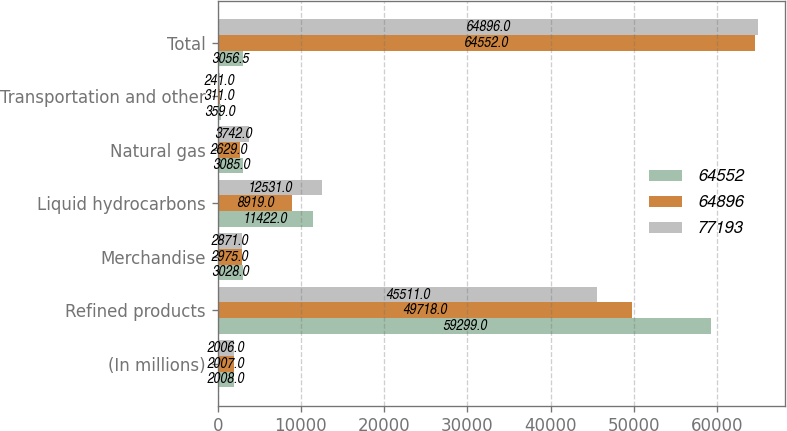<chart> <loc_0><loc_0><loc_500><loc_500><stacked_bar_chart><ecel><fcel>(In millions)<fcel>Refined products<fcel>Merchandise<fcel>Liquid hydrocarbons<fcel>Natural gas<fcel>Transportation and other<fcel>Total<nl><fcel>64552<fcel>2008<fcel>59299<fcel>3028<fcel>11422<fcel>3085<fcel>359<fcel>3056.5<nl><fcel>64896<fcel>2007<fcel>49718<fcel>2975<fcel>8919<fcel>2629<fcel>311<fcel>64552<nl><fcel>77193<fcel>2006<fcel>45511<fcel>2871<fcel>12531<fcel>3742<fcel>241<fcel>64896<nl></chart> 